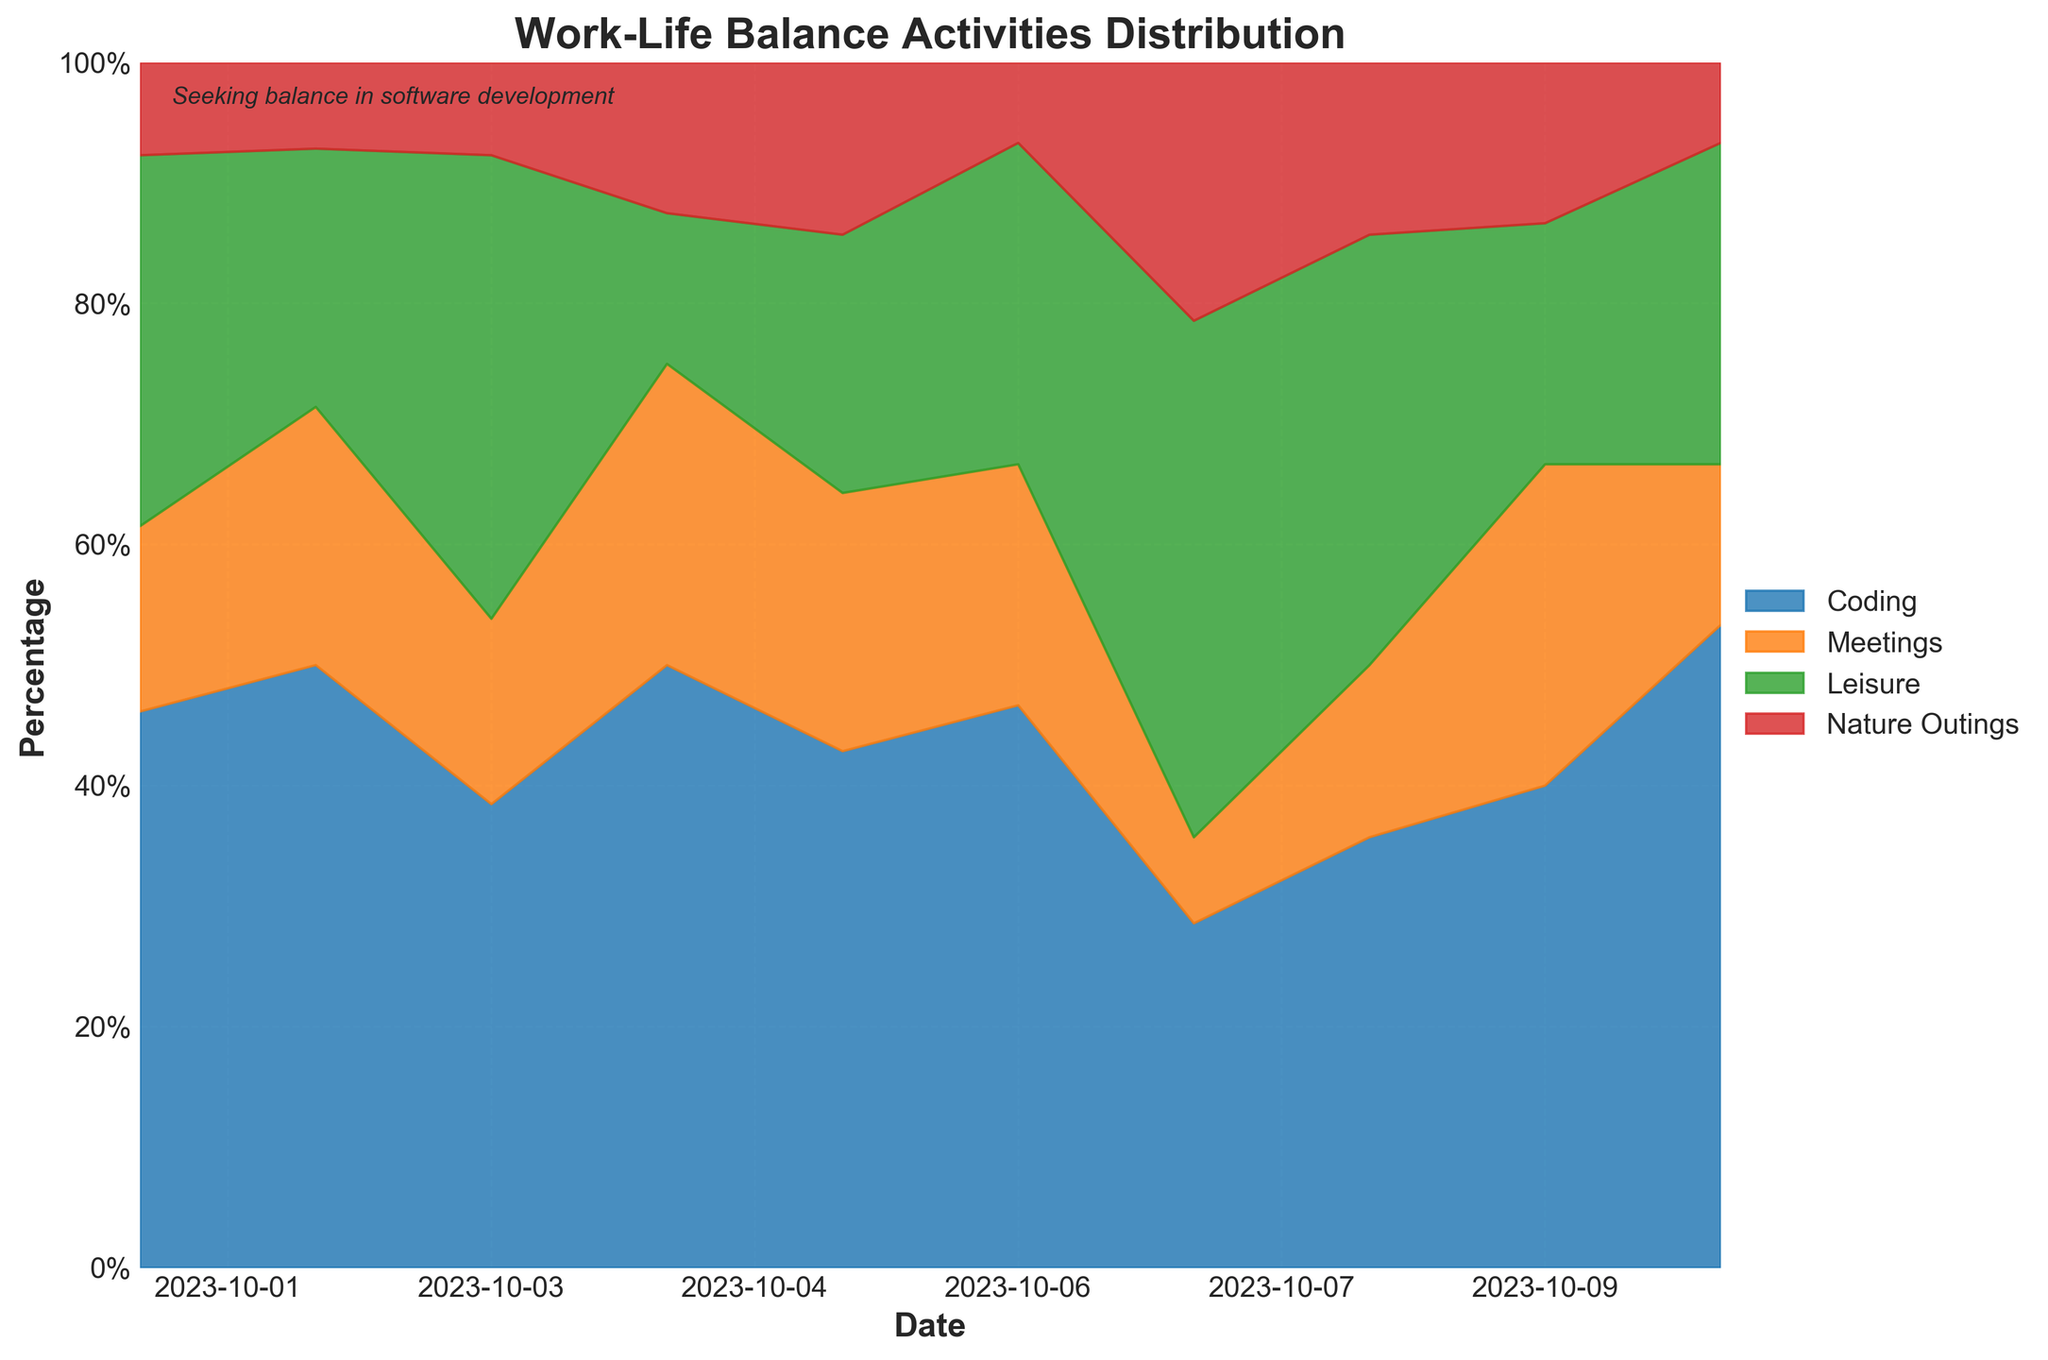What is the title of the chart? The title is typically positioned at the top of the chart and describes the main focus of the visual. Here, it's clear at the top center.
Answer: Work-Life Balance Activities Distribution How many days are covered in this chart? By examining the x-axis, which represents the date, we notice the range encompasses October 1st to October 10th. Counting these dates gives us 10 days.
Answer: 10 Which activity occupies the largest space on October 4th? From the stacked areas, we can see that the uppermost color-coded segment on October 4th is the light green one, representing 'Coding'.
Answer: Coding On which date does 'Nature Outings' have the highest percentage? We need to find where the top red section is largest. By observation, it is largest on October 7th.
Answer: October 7th Between which two dates did 'Leisure' see a noticeable increase? By following the dark green area, we notice a significant jump between October 6th and October 7th.
Answer: October 6th and October 7th Compare the percentages of 'Meetings' on October 1st and October 10th.Which day has a higher percentage? Look at the second orange segment from the bottom for both dates; we can see October 1st has a smaller orange section compared to October 10th.
Answer: October 10th How does 'Coding' activity change from October 1st to October 10th? Looking at the blue area (bottom), we start with a small portion on October 1st and see it expand to a larger area by October 10th.
Answer: Increases What is the most consistent activity throughout the period? The most consistent activity would show the least variation. By visual inspection, 'Nature Outings' (red at the top) does not change much throughout the dates.
Answer: Nature Outings What can you infer about the developer’s work-life balance on weekends versus weekdays? By examining the pattern, we find that on weekends (October 7th and 8th), 'Leisure' and 'Nature Outings' percentages are higher compared to weekdays, indicating a shift towards non-work activities.
Answer: Relaxation or more leisure activities on weekends Which activity has the smallest average percentage over the whole period? To determine this, we need to visually assess the average width of each colored area across all dates. 'Nature Outings' (red) has the smallest area consistently.
Answer: Nature Outings 